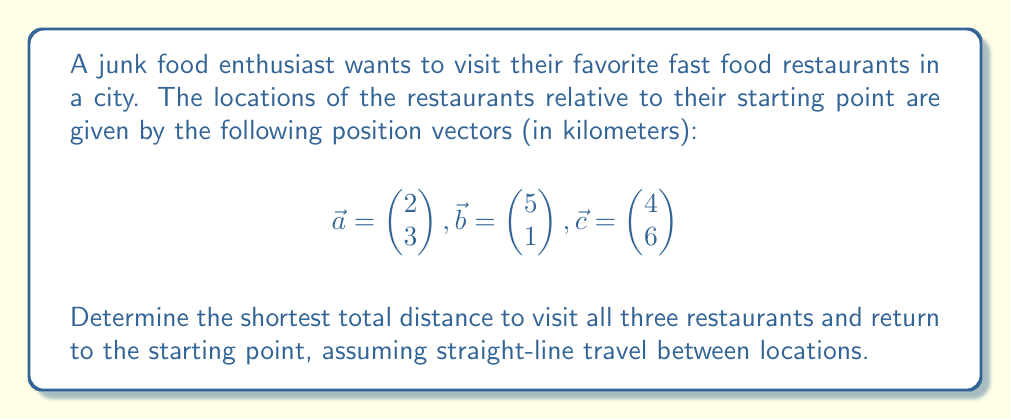What is the answer to this math problem? To find the shortest total distance, we need to calculate the distances between all points and determine the optimal route. Let's approach this step-by-step:

1) First, calculate the distances between all points:

   Starting point to $\vec{a}$: $\|\vec{a}\| = \sqrt{2^2 + 3^2} = \sqrt{13}$
   Starting point to $\vec{b}$: $\|\vec{b}\| = \sqrt{5^2 + 1^2} = \sqrt{26}$
   Starting point to $\vec{c}$: $\|\vec{c}\| = \sqrt{4^2 + 6^2} = \sqrt{52}$

   $\vec{a}$ to $\vec{b}$: $\|\vec{b} - \vec{a}\| = \left\|\begin{pmatrix} 3 \\ -2 \end{pmatrix}\right\| = \sqrt{13}$
   $\vec{b}$ to $\vec{c}$: $\|\vec{c} - \vec{b}\| = \left\|\begin{pmatrix} -1 \\ 5 \end{pmatrix}\right\| = \sqrt{26}$
   $\vec{c}$ to $\vec{a}$: $\|\vec{a} - \vec{c}\| = \left\|\begin{pmatrix} -2 \\ -3 \end{pmatrix}\right\| = \sqrt{13}$

2) The possible routes are:
   Start → $\vec{a}$ → $\vec{b}$ → $\vec{c}$ → Start
   Start → $\vec{a}$ → $\vec{c}$ → $\vec{b}$ → Start
   Start → $\vec{b}$ → $\vec{a}$ → $\vec{c}$ → Start
   Start → $\vec{b}$ → $\vec{c}$ → $\vec{a}$ → Start
   Start → $\vec{c}$ → $\vec{a}$ → $\vec{b}$ → Start
   Start → $\vec{c}$ → $\vec{b}$ → $\vec{a}$ → Start

3) Calculate the total distance for each route:
   Route 1: $\sqrt{13} + \sqrt{13} + \sqrt{26} + \sqrt{52} = 2\sqrt{13} + \sqrt{26} + \sqrt{52}$
   Route 2: $\sqrt{13} + \sqrt{13} + \sqrt{26} + \sqrt{26} = 2\sqrt{13} + 2\sqrt{26}$
   Route 3: $\sqrt{26} + \sqrt{13} + \sqrt{13} + \sqrt{52} = 2\sqrt{13} + \sqrt{26} + \sqrt{52}$
   Route 4: $\sqrt{26} + \sqrt{26} + \sqrt{13} + \sqrt{13} = 2\sqrt{13} + 2\sqrt{26}$
   Route 5: $\sqrt{52} + \sqrt{13} + \sqrt{13} + \sqrt{26} = 2\sqrt{13} + \sqrt{26} + \sqrt{52}$
   Route 6: $\sqrt{52} + \sqrt{26} + \sqrt{13} + \sqrt{13} = 2\sqrt{13} + \sqrt{26} + \sqrt{52}$

4) The shortest route is either Route 2 or Route 4, both with a total distance of $2\sqrt{13} + 2\sqrt{26}$ km.
Answer: $2\sqrt{13} + 2\sqrt{26}$ km 